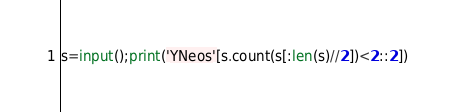<code> <loc_0><loc_0><loc_500><loc_500><_Python_>s=input();print('YNeos'[s.count(s[:len(s)//2])<2::2])</code> 